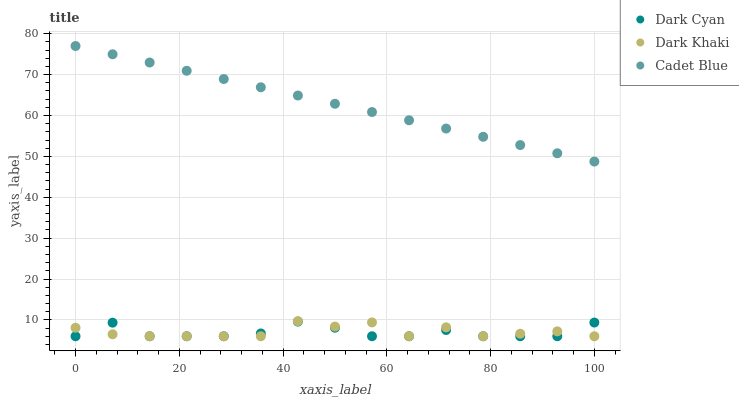Does Dark Cyan have the minimum area under the curve?
Answer yes or no. Yes. Does Cadet Blue have the maximum area under the curve?
Answer yes or no. Yes. Does Dark Khaki have the minimum area under the curve?
Answer yes or no. No. Does Dark Khaki have the maximum area under the curve?
Answer yes or no. No. Is Cadet Blue the smoothest?
Answer yes or no. Yes. Is Dark Khaki the roughest?
Answer yes or no. Yes. Is Dark Khaki the smoothest?
Answer yes or no. No. Is Cadet Blue the roughest?
Answer yes or no. No. Does Dark Cyan have the lowest value?
Answer yes or no. Yes. Does Cadet Blue have the lowest value?
Answer yes or no. No. Does Cadet Blue have the highest value?
Answer yes or no. Yes. Does Dark Khaki have the highest value?
Answer yes or no. No. Is Dark Khaki less than Cadet Blue?
Answer yes or no. Yes. Is Cadet Blue greater than Dark Cyan?
Answer yes or no. Yes. Does Dark Khaki intersect Dark Cyan?
Answer yes or no. Yes. Is Dark Khaki less than Dark Cyan?
Answer yes or no. No. Is Dark Khaki greater than Dark Cyan?
Answer yes or no. No. Does Dark Khaki intersect Cadet Blue?
Answer yes or no. No. 